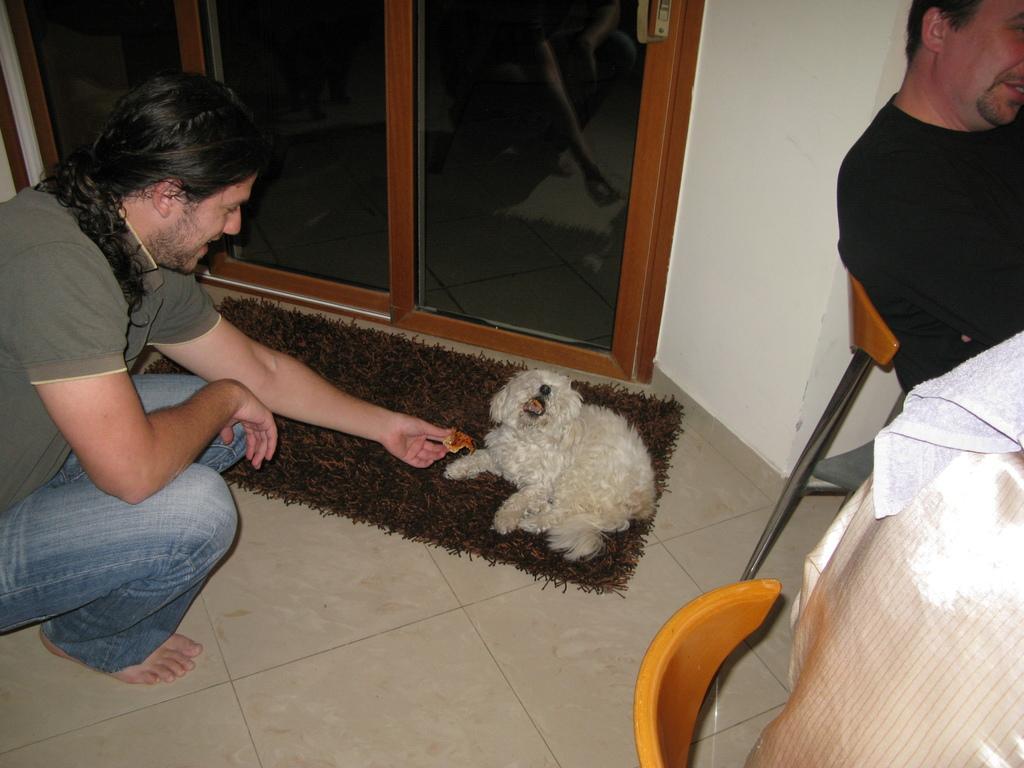In one or two sentences, can you explain what this image depicts? There are three persons in this room, two are sitting on these yellow chairs. One guy is crouching over here,there is a dog which is resting on this brown mat and the guy who is crouching over here feeding something to this dog and there is a wall and glass door,at the top of the image there is a handle 